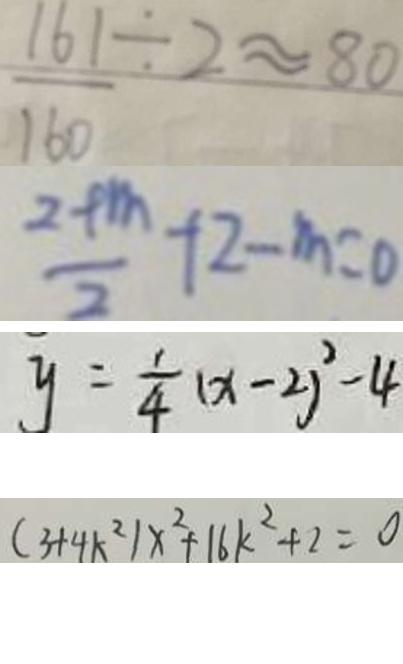<formula> <loc_0><loc_0><loc_500><loc_500>\frac { 1 6 1 } { 1 6 0 } \div 2 \approx 8 0 
 \frac { 2 + m } { 2 } + 2 - m = 0 
 y = \frac { 1 } { 4 } ( x - 2 ) ^ { 2 } - 4 
 ( 3 + 4 k ^ { 2 } ) x ^ { 2 } + 1 6 k ^ { 2 } + 2 = 0</formula> 